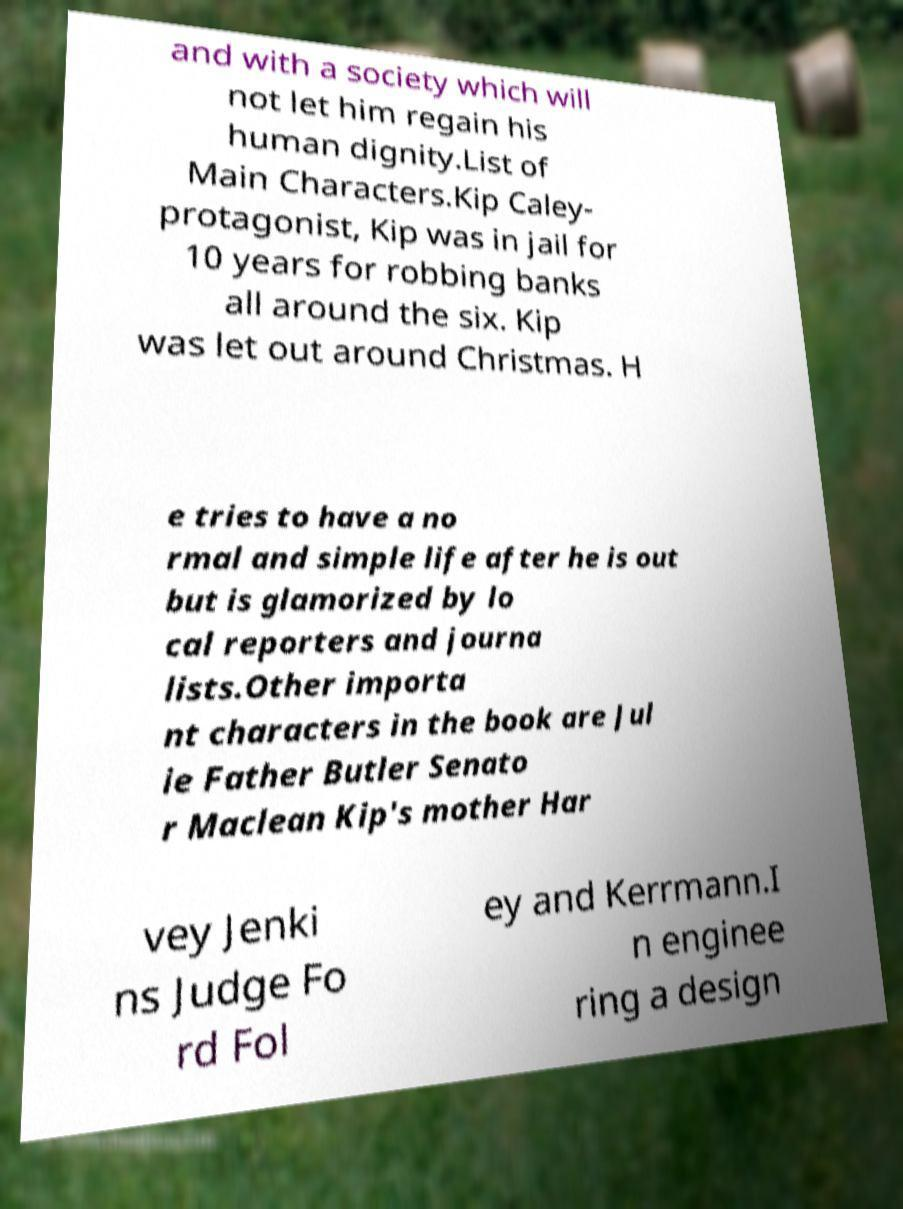Could you assist in decoding the text presented in this image and type it out clearly? and with a society which will not let him regain his human dignity.List of Main Characters.Kip Caley- protagonist, Kip was in jail for 10 years for robbing banks all around the six. Kip was let out around Christmas. H e tries to have a no rmal and simple life after he is out but is glamorized by lo cal reporters and journa lists.Other importa nt characters in the book are Jul ie Father Butler Senato r Maclean Kip's mother Har vey Jenki ns Judge Fo rd Fol ey and Kerrmann.I n enginee ring a design 